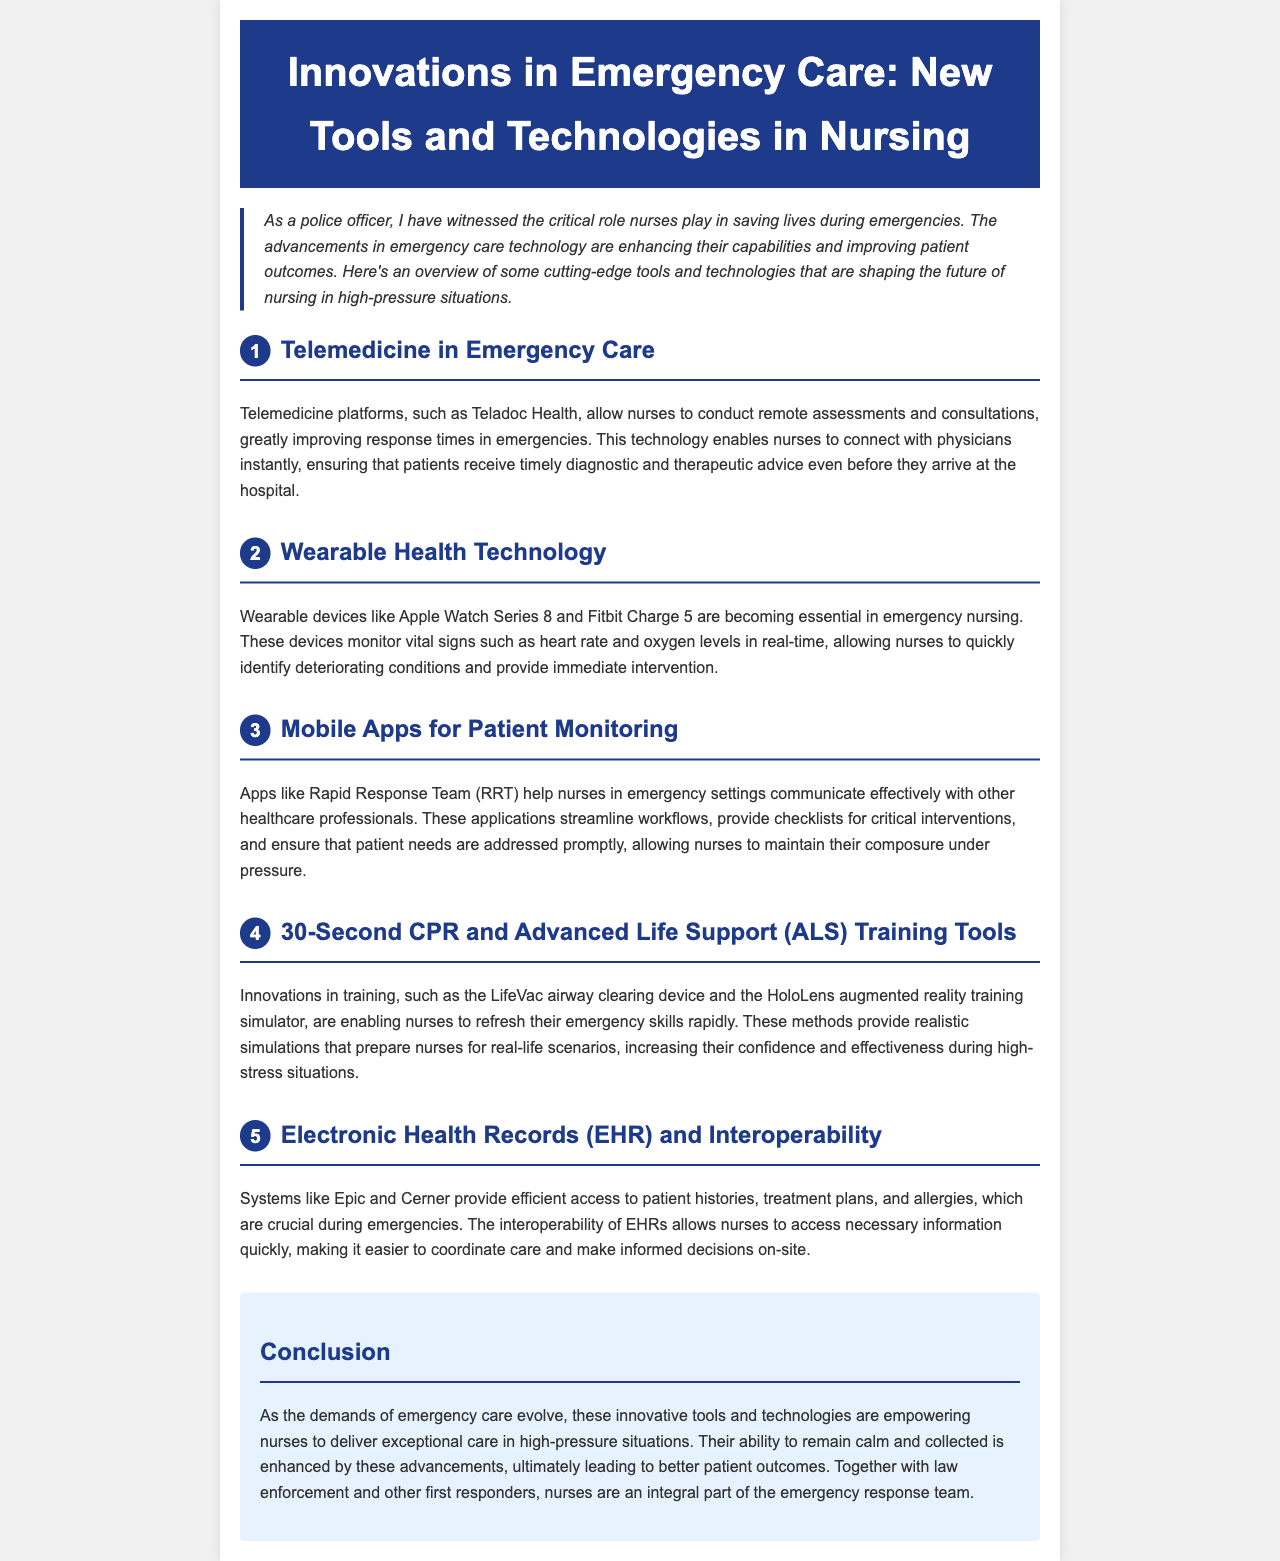What technology allows nurses to conduct remote assessments? The document mentions telemedicine platforms, such as Teladoc Health, that enable remote assessments.
Answer: Telemedicine platforms What wearable devices are mentioned for monitoring vital signs? The document lists Apple Watch Series 8 and Fitbit Charge 5 as wearable devices for monitoring vital signs.
Answer: Apple Watch Series 8 and Fitbit Charge 5 Which app helps nurses communicate effectively in emergencies? The document refers to the Rapid Response Team (RRT) app as a communication tool for nurses in emergencies.
Answer: Rapid Response Team (RRT) What is the main advantage of Electronic Health Records (EHR) systems in emergencies? The document states that EHR systems like Epic and Cerner provide efficient access to patient histories that are crucial during emergencies.
Answer: Efficient access to patient histories Name one innovative training tool mentioned for CPR and ALS training. The document mentions the LifeVac airway clearing device as one of the innovative training tools for CPR and ALS training.
Answer: LifeVac How do these innovations empower nurses in emergency care? The document explains that these innovations enhance nurses' ability to deliver exceptional care and remain calm under pressure.
Answer: Enhance nurses' ability What overarching role do nurses play in emergency responses? The document highlights that nurses are an integral part of the emergency response team along with law enforcement and other responders.
Answer: Integral part of the emergency response team Which section discusses wearable technology? The section labeled "2" covers wearable health technology and its importance in emergency nursing.
Answer: Section 2 